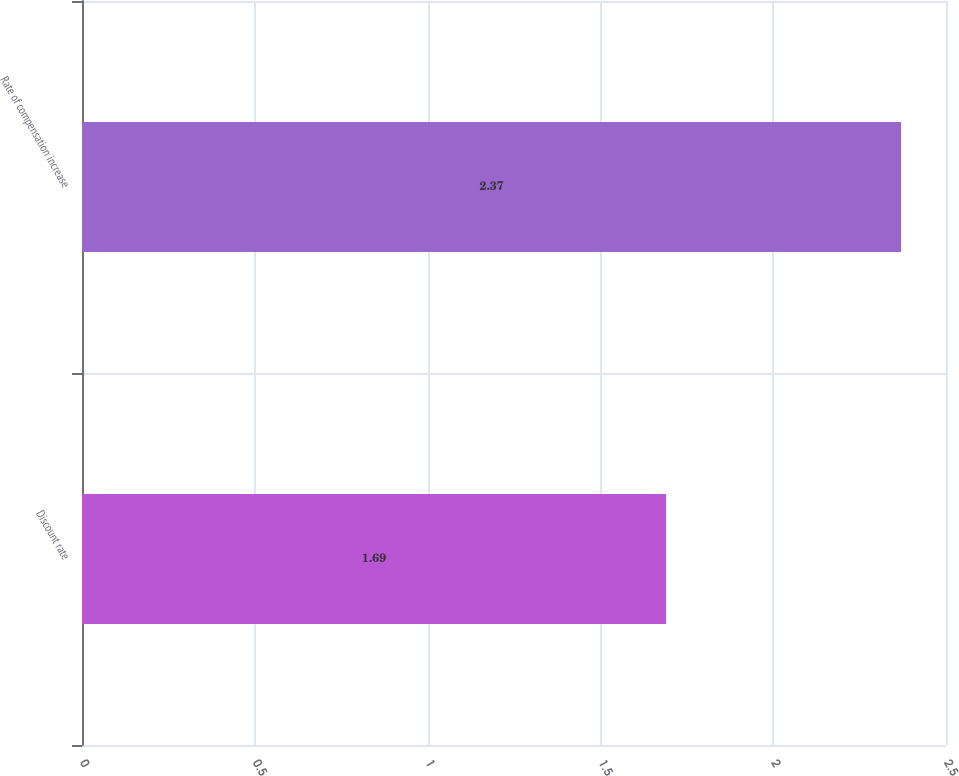<chart> <loc_0><loc_0><loc_500><loc_500><bar_chart><fcel>Discount rate<fcel>Rate of compensation increase<nl><fcel>1.69<fcel>2.37<nl></chart> 